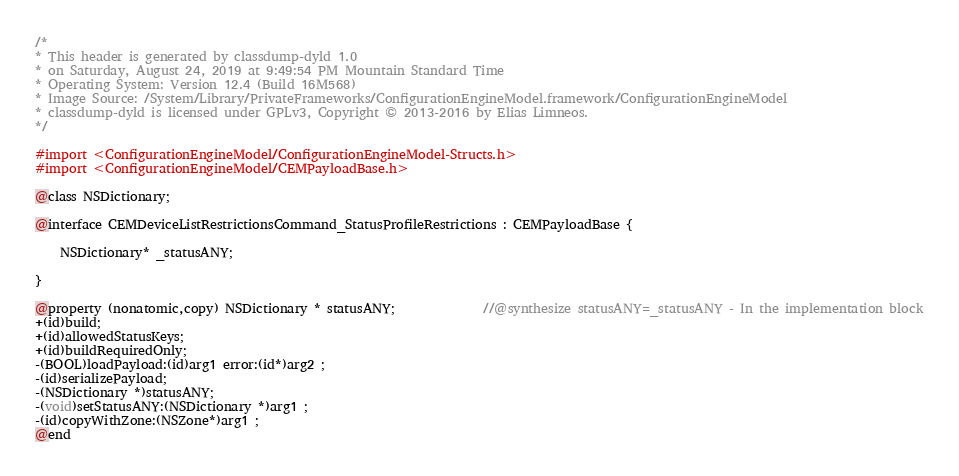Convert code to text. <code><loc_0><loc_0><loc_500><loc_500><_C_>/*
* This header is generated by classdump-dyld 1.0
* on Saturday, August 24, 2019 at 9:49:54 PM Mountain Standard Time
* Operating System: Version 12.4 (Build 16M568)
* Image Source: /System/Library/PrivateFrameworks/ConfigurationEngineModel.framework/ConfigurationEngineModel
* classdump-dyld is licensed under GPLv3, Copyright © 2013-2016 by Elias Limneos.
*/

#import <ConfigurationEngineModel/ConfigurationEngineModel-Structs.h>
#import <ConfigurationEngineModel/CEMPayloadBase.h>

@class NSDictionary;

@interface CEMDeviceListRestrictionsCommand_StatusProfileRestrictions : CEMPayloadBase {

	NSDictionary* _statusANY;

}

@property (nonatomic,copy) NSDictionary * statusANY;              //@synthesize statusANY=_statusANY - In the implementation block
+(id)build;
+(id)allowedStatusKeys;
+(id)buildRequiredOnly;
-(BOOL)loadPayload:(id)arg1 error:(id*)arg2 ;
-(id)serializePayload;
-(NSDictionary *)statusANY;
-(void)setStatusANY:(NSDictionary *)arg1 ;
-(id)copyWithZone:(NSZone*)arg1 ;
@end

</code> 